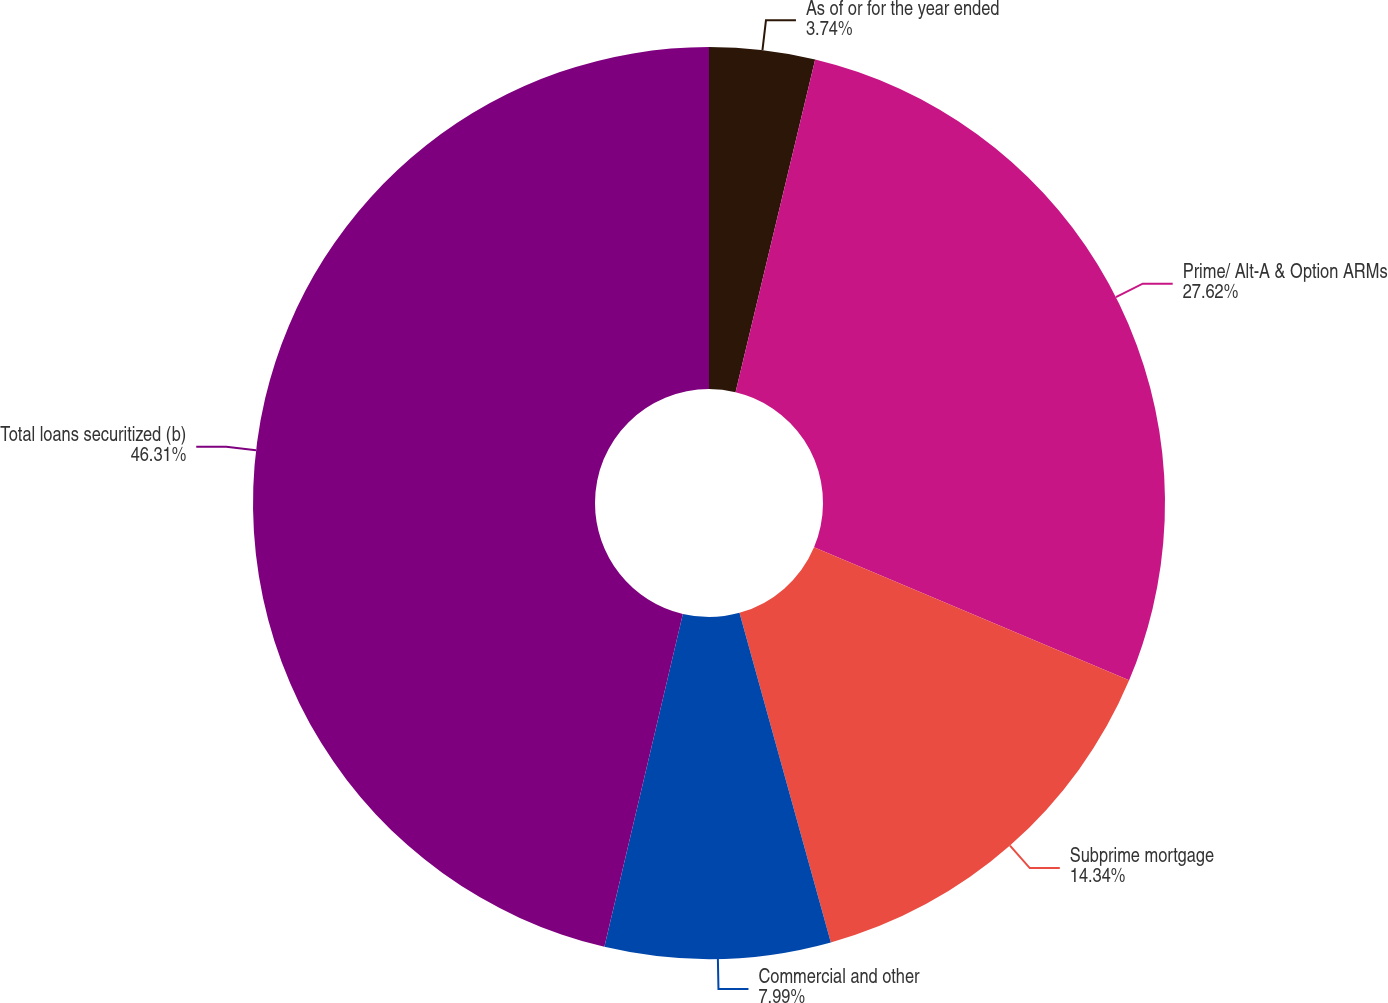Convert chart. <chart><loc_0><loc_0><loc_500><loc_500><pie_chart><fcel>As of or for the year ended<fcel>Prime/ Alt-A & Option ARMs<fcel>Subprime mortgage<fcel>Commercial and other<fcel>Total loans securitized (b)<nl><fcel>3.74%<fcel>27.62%<fcel>14.34%<fcel>7.99%<fcel>46.32%<nl></chart> 